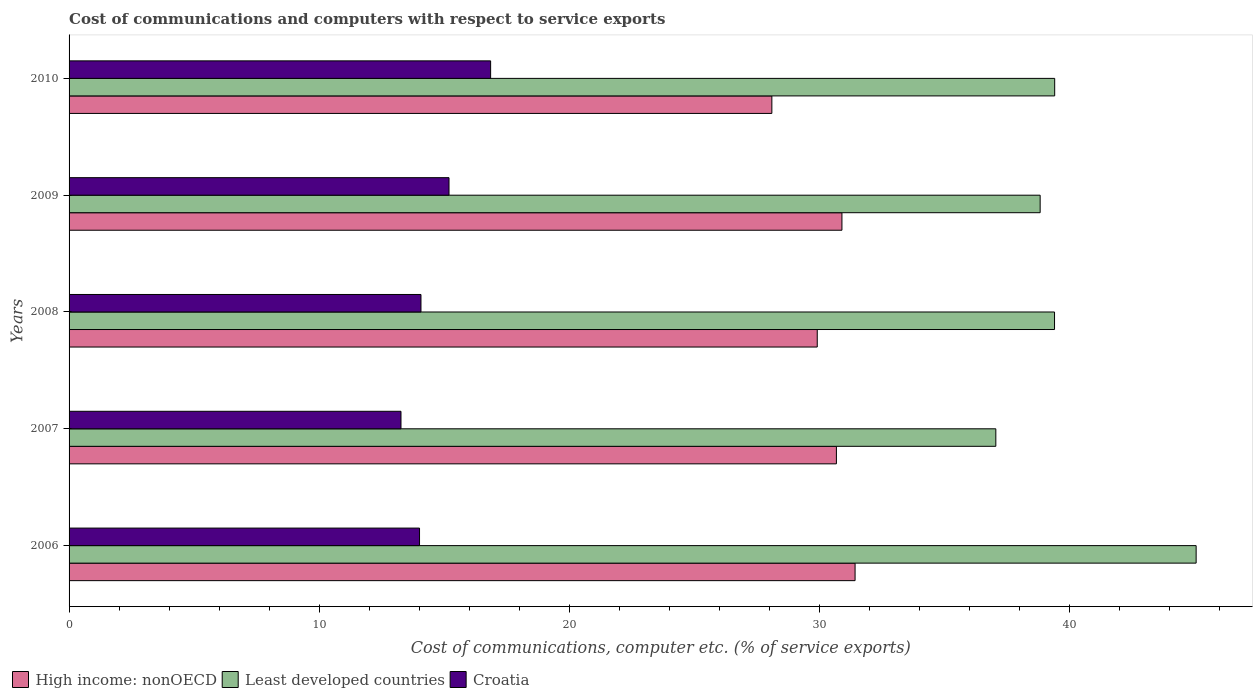How many different coloured bars are there?
Make the answer very short. 3. How many groups of bars are there?
Give a very brief answer. 5. How many bars are there on the 4th tick from the top?
Keep it short and to the point. 3. How many bars are there on the 3rd tick from the bottom?
Provide a succinct answer. 3. In how many cases, is the number of bars for a given year not equal to the number of legend labels?
Make the answer very short. 0. What is the cost of communications and computers in High income: nonOECD in 2006?
Your answer should be very brief. 31.42. Across all years, what is the maximum cost of communications and computers in Croatia?
Keep it short and to the point. 16.85. Across all years, what is the minimum cost of communications and computers in Least developed countries?
Your answer should be compact. 37.05. In which year was the cost of communications and computers in Croatia minimum?
Ensure brevity in your answer.  2007. What is the total cost of communications and computers in Croatia in the graph?
Your answer should be compact. 73.39. What is the difference between the cost of communications and computers in High income: nonOECD in 2007 and that in 2009?
Offer a very short reply. -0.22. What is the difference between the cost of communications and computers in High income: nonOECD in 2009 and the cost of communications and computers in Least developed countries in 2007?
Offer a terse response. -6.15. What is the average cost of communications and computers in Least developed countries per year?
Keep it short and to the point. 39.94. In the year 2010, what is the difference between the cost of communications and computers in Croatia and cost of communications and computers in Least developed countries?
Ensure brevity in your answer.  -22.55. In how many years, is the cost of communications and computers in Least developed countries greater than 26 %?
Your answer should be very brief. 5. What is the ratio of the cost of communications and computers in Croatia in 2008 to that in 2009?
Your answer should be compact. 0.93. What is the difference between the highest and the second highest cost of communications and computers in High income: nonOECD?
Ensure brevity in your answer.  0.53. What is the difference between the highest and the lowest cost of communications and computers in High income: nonOECD?
Make the answer very short. 3.33. In how many years, is the cost of communications and computers in High income: nonOECD greater than the average cost of communications and computers in High income: nonOECD taken over all years?
Offer a terse response. 3. What does the 1st bar from the top in 2010 represents?
Make the answer very short. Croatia. What does the 3rd bar from the bottom in 2010 represents?
Keep it short and to the point. Croatia. Is it the case that in every year, the sum of the cost of communications and computers in Least developed countries and cost of communications and computers in Croatia is greater than the cost of communications and computers in High income: nonOECD?
Your response must be concise. Yes. How many bars are there?
Make the answer very short. 15. Are all the bars in the graph horizontal?
Ensure brevity in your answer.  Yes. How many years are there in the graph?
Keep it short and to the point. 5. Where does the legend appear in the graph?
Provide a short and direct response. Bottom left. How are the legend labels stacked?
Make the answer very short. Horizontal. What is the title of the graph?
Your response must be concise. Cost of communications and computers with respect to service exports. What is the label or title of the X-axis?
Give a very brief answer. Cost of communications, computer etc. (% of service exports). What is the Cost of communications, computer etc. (% of service exports) of High income: nonOECD in 2006?
Your answer should be compact. 31.42. What is the Cost of communications, computer etc. (% of service exports) of Least developed countries in 2006?
Give a very brief answer. 45.06. What is the Cost of communications, computer etc. (% of service exports) in Croatia in 2006?
Provide a short and direct response. 14.01. What is the Cost of communications, computer etc. (% of service exports) of High income: nonOECD in 2007?
Offer a very short reply. 30.68. What is the Cost of communications, computer etc. (% of service exports) in Least developed countries in 2007?
Your response must be concise. 37.05. What is the Cost of communications, computer etc. (% of service exports) of Croatia in 2007?
Give a very brief answer. 13.27. What is the Cost of communications, computer etc. (% of service exports) of High income: nonOECD in 2008?
Your answer should be compact. 29.91. What is the Cost of communications, computer etc. (% of service exports) of Least developed countries in 2008?
Ensure brevity in your answer.  39.4. What is the Cost of communications, computer etc. (% of service exports) in Croatia in 2008?
Your answer should be very brief. 14.07. What is the Cost of communications, computer etc. (% of service exports) in High income: nonOECD in 2009?
Your answer should be compact. 30.9. What is the Cost of communications, computer etc. (% of service exports) in Least developed countries in 2009?
Your answer should be very brief. 38.82. What is the Cost of communications, computer etc. (% of service exports) in Croatia in 2009?
Keep it short and to the point. 15.19. What is the Cost of communications, computer etc. (% of service exports) of High income: nonOECD in 2010?
Provide a succinct answer. 28.09. What is the Cost of communications, computer etc. (% of service exports) of Least developed countries in 2010?
Your answer should be very brief. 39.4. What is the Cost of communications, computer etc. (% of service exports) in Croatia in 2010?
Offer a terse response. 16.85. Across all years, what is the maximum Cost of communications, computer etc. (% of service exports) in High income: nonOECD?
Your answer should be compact. 31.42. Across all years, what is the maximum Cost of communications, computer etc. (% of service exports) in Least developed countries?
Provide a succinct answer. 45.06. Across all years, what is the maximum Cost of communications, computer etc. (% of service exports) of Croatia?
Provide a short and direct response. 16.85. Across all years, what is the minimum Cost of communications, computer etc. (% of service exports) of High income: nonOECD?
Provide a short and direct response. 28.09. Across all years, what is the minimum Cost of communications, computer etc. (% of service exports) of Least developed countries?
Provide a short and direct response. 37.05. Across all years, what is the minimum Cost of communications, computer etc. (% of service exports) in Croatia?
Provide a succinct answer. 13.27. What is the total Cost of communications, computer etc. (% of service exports) in High income: nonOECD in the graph?
Provide a short and direct response. 151. What is the total Cost of communications, computer etc. (% of service exports) in Least developed countries in the graph?
Your answer should be compact. 199.72. What is the total Cost of communications, computer etc. (% of service exports) of Croatia in the graph?
Your answer should be very brief. 73.39. What is the difference between the Cost of communications, computer etc. (% of service exports) of High income: nonOECD in 2006 and that in 2007?
Offer a terse response. 0.75. What is the difference between the Cost of communications, computer etc. (% of service exports) of Least developed countries in 2006 and that in 2007?
Offer a very short reply. 8.01. What is the difference between the Cost of communications, computer etc. (% of service exports) in Croatia in 2006 and that in 2007?
Offer a terse response. 0.74. What is the difference between the Cost of communications, computer etc. (% of service exports) in High income: nonOECD in 2006 and that in 2008?
Your response must be concise. 1.51. What is the difference between the Cost of communications, computer etc. (% of service exports) in Least developed countries in 2006 and that in 2008?
Ensure brevity in your answer.  5.66. What is the difference between the Cost of communications, computer etc. (% of service exports) of Croatia in 2006 and that in 2008?
Offer a very short reply. -0.06. What is the difference between the Cost of communications, computer etc. (% of service exports) in High income: nonOECD in 2006 and that in 2009?
Your answer should be very brief. 0.53. What is the difference between the Cost of communications, computer etc. (% of service exports) of Least developed countries in 2006 and that in 2009?
Your answer should be very brief. 6.24. What is the difference between the Cost of communications, computer etc. (% of service exports) of Croatia in 2006 and that in 2009?
Offer a very short reply. -1.18. What is the difference between the Cost of communications, computer etc. (% of service exports) of High income: nonOECD in 2006 and that in 2010?
Ensure brevity in your answer.  3.33. What is the difference between the Cost of communications, computer etc. (% of service exports) of Least developed countries in 2006 and that in 2010?
Provide a short and direct response. 5.65. What is the difference between the Cost of communications, computer etc. (% of service exports) of Croatia in 2006 and that in 2010?
Your answer should be very brief. -2.84. What is the difference between the Cost of communications, computer etc. (% of service exports) in High income: nonOECD in 2007 and that in 2008?
Give a very brief answer. 0.77. What is the difference between the Cost of communications, computer etc. (% of service exports) in Least developed countries in 2007 and that in 2008?
Offer a terse response. -2.35. What is the difference between the Cost of communications, computer etc. (% of service exports) of Croatia in 2007 and that in 2008?
Give a very brief answer. -0.8. What is the difference between the Cost of communications, computer etc. (% of service exports) in High income: nonOECD in 2007 and that in 2009?
Your answer should be compact. -0.22. What is the difference between the Cost of communications, computer etc. (% of service exports) in Least developed countries in 2007 and that in 2009?
Your response must be concise. -1.77. What is the difference between the Cost of communications, computer etc. (% of service exports) of Croatia in 2007 and that in 2009?
Your response must be concise. -1.92. What is the difference between the Cost of communications, computer etc. (% of service exports) in High income: nonOECD in 2007 and that in 2010?
Make the answer very short. 2.58. What is the difference between the Cost of communications, computer etc. (% of service exports) in Least developed countries in 2007 and that in 2010?
Give a very brief answer. -2.35. What is the difference between the Cost of communications, computer etc. (% of service exports) of Croatia in 2007 and that in 2010?
Provide a succinct answer. -3.58. What is the difference between the Cost of communications, computer etc. (% of service exports) of High income: nonOECD in 2008 and that in 2009?
Offer a very short reply. -0.99. What is the difference between the Cost of communications, computer etc. (% of service exports) in Least developed countries in 2008 and that in 2009?
Keep it short and to the point. 0.57. What is the difference between the Cost of communications, computer etc. (% of service exports) in Croatia in 2008 and that in 2009?
Ensure brevity in your answer.  -1.12. What is the difference between the Cost of communications, computer etc. (% of service exports) of High income: nonOECD in 2008 and that in 2010?
Keep it short and to the point. 1.81. What is the difference between the Cost of communications, computer etc. (% of service exports) in Least developed countries in 2008 and that in 2010?
Make the answer very short. -0.01. What is the difference between the Cost of communications, computer etc. (% of service exports) of Croatia in 2008 and that in 2010?
Your answer should be compact. -2.78. What is the difference between the Cost of communications, computer etc. (% of service exports) of High income: nonOECD in 2009 and that in 2010?
Your answer should be very brief. 2.8. What is the difference between the Cost of communications, computer etc. (% of service exports) of Least developed countries in 2009 and that in 2010?
Provide a succinct answer. -0.58. What is the difference between the Cost of communications, computer etc. (% of service exports) in Croatia in 2009 and that in 2010?
Offer a terse response. -1.66. What is the difference between the Cost of communications, computer etc. (% of service exports) in High income: nonOECD in 2006 and the Cost of communications, computer etc. (% of service exports) in Least developed countries in 2007?
Make the answer very short. -5.63. What is the difference between the Cost of communications, computer etc. (% of service exports) of High income: nonOECD in 2006 and the Cost of communications, computer etc. (% of service exports) of Croatia in 2007?
Offer a terse response. 18.15. What is the difference between the Cost of communications, computer etc. (% of service exports) of Least developed countries in 2006 and the Cost of communications, computer etc. (% of service exports) of Croatia in 2007?
Offer a terse response. 31.79. What is the difference between the Cost of communications, computer etc. (% of service exports) of High income: nonOECD in 2006 and the Cost of communications, computer etc. (% of service exports) of Least developed countries in 2008?
Offer a very short reply. -7.97. What is the difference between the Cost of communications, computer etc. (% of service exports) in High income: nonOECD in 2006 and the Cost of communications, computer etc. (% of service exports) in Croatia in 2008?
Your response must be concise. 17.35. What is the difference between the Cost of communications, computer etc. (% of service exports) of Least developed countries in 2006 and the Cost of communications, computer etc. (% of service exports) of Croatia in 2008?
Provide a succinct answer. 30.99. What is the difference between the Cost of communications, computer etc. (% of service exports) in High income: nonOECD in 2006 and the Cost of communications, computer etc. (% of service exports) in Least developed countries in 2009?
Offer a terse response. -7.4. What is the difference between the Cost of communications, computer etc. (% of service exports) of High income: nonOECD in 2006 and the Cost of communications, computer etc. (% of service exports) of Croatia in 2009?
Keep it short and to the point. 16.23. What is the difference between the Cost of communications, computer etc. (% of service exports) in Least developed countries in 2006 and the Cost of communications, computer etc. (% of service exports) in Croatia in 2009?
Your response must be concise. 29.87. What is the difference between the Cost of communications, computer etc. (% of service exports) of High income: nonOECD in 2006 and the Cost of communications, computer etc. (% of service exports) of Least developed countries in 2010?
Your response must be concise. -7.98. What is the difference between the Cost of communications, computer etc. (% of service exports) in High income: nonOECD in 2006 and the Cost of communications, computer etc. (% of service exports) in Croatia in 2010?
Offer a terse response. 14.57. What is the difference between the Cost of communications, computer etc. (% of service exports) of Least developed countries in 2006 and the Cost of communications, computer etc. (% of service exports) of Croatia in 2010?
Your answer should be very brief. 28.2. What is the difference between the Cost of communications, computer etc. (% of service exports) of High income: nonOECD in 2007 and the Cost of communications, computer etc. (% of service exports) of Least developed countries in 2008?
Your answer should be compact. -8.72. What is the difference between the Cost of communications, computer etc. (% of service exports) in High income: nonOECD in 2007 and the Cost of communications, computer etc. (% of service exports) in Croatia in 2008?
Ensure brevity in your answer.  16.61. What is the difference between the Cost of communications, computer etc. (% of service exports) of Least developed countries in 2007 and the Cost of communications, computer etc. (% of service exports) of Croatia in 2008?
Your answer should be compact. 22.98. What is the difference between the Cost of communications, computer etc. (% of service exports) of High income: nonOECD in 2007 and the Cost of communications, computer etc. (% of service exports) of Least developed countries in 2009?
Your response must be concise. -8.15. What is the difference between the Cost of communications, computer etc. (% of service exports) in High income: nonOECD in 2007 and the Cost of communications, computer etc. (% of service exports) in Croatia in 2009?
Your response must be concise. 15.49. What is the difference between the Cost of communications, computer etc. (% of service exports) in Least developed countries in 2007 and the Cost of communications, computer etc. (% of service exports) in Croatia in 2009?
Offer a very short reply. 21.86. What is the difference between the Cost of communications, computer etc. (% of service exports) of High income: nonOECD in 2007 and the Cost of communications, computer etc. (% of service exports) of Least developed countries in 2010?
Keep it short and to the point. -8.73. What is the difference between the Cost of communications, computer etc. (% of service exports) in High income: nonOECD in 2007 and the Cost of communications, computer etc. (% of service exports) in Croatia in 2010?
Provide a succinct answer. 13.82. What is the difference between the Cost of communications, computer etc. (% of service exports) of Least developed countries in 2007 and the Cost of communications, computer etc. (% of service exports) of Croatia in 2010?
Offer a very short reply. 20.2. What is the difference between the Cost of communications, computer etc. (% of service exports) in High income: nonOECD in 2008 and the Cost of communications, computer etc. (% of service exports) in Least developed countries in 2009?
Give a very brief answer. -8.91. What is the difference between the Cost of communications, computer etc. (% of service exports) of High income: nonOECD in 2008 and the Cost of communications, computer etc. (% of service exports) of Croatia in 2009?
Your response must be concise. 14.72. What is the difference between the Cost of communications, computer etc. (% of service exports) in Least developed countries in 2008 and the Cost of communications, computer etc. (% of service exports) in Croatia in 2009?
Make the answer very short. 24.21. What is the difference between the Cost of communications, computer etc. (% of service exports) in High income: nonOECD in 2008 and the Cost of communications, computer etc. (% of service exports) in Least developed countries in 2010?
Provide a succinct answer. -9.49. What is the difference between the Cost of communications, computer etc. (% of service exports) in High income: nonOECD in 2008 and the Cost of communications, computer etc. (% of service exports) in Croatia in 2010?
Keep it short and to the point. 13.06. What is the difference between the Cost of communications, computer etc. (% of service exports) of Least developed countries in 2008 and the Cost of communications, computer etc. (% of service exports) of Croatia in 2010?
Your answer should be very brief. 22.54. What is the difference between the Cost of communications, computer etc. (% of service exports) of High income: nonOECD in 2009 and the Cost of communications, computer etc. (% of service exports) of Least developed countries in 2010?
Provide a succinct answer. -8.5. What is the difference between the Cost of communications, computer etc. (% of service exports) of High income: nonOECD in 2009 and the Cost of communications, computer etc. (% of service exports) of Croatia in 2010?
Provide a short and direct response. 14.04. What is the difference between the Cost of communications, computer etc. (% of service exports) in Least developed countries in 2009 and the Cost of communications, computer etc. (% of service exports) in Croatia in 2010?
Your answer should be very brief. 21.97. What is the average Cost of communications, computer etc. (% of service exports) in High income: nonOECD per year?
Offer a terse response. 30.2. What is the average Cost of communications, computer etc. (% of service exports) in Least developed countries per year?
Ensure brevity in your answer.  39.94. What is the average Cost of communications, computer etc. (% of service exports) in Croatia per year?
Your answer should be very brief. 14.68. In the year 2006, what is the difference between the Cost of communications, computer etc. (% of service exports) of High income: nonOECD and Cost of communications, computer etc. (% of service exports) of Least developed countries?
Offer a terse response. -13.63. In the year 2006, what is the difference between the Cost of communications, computer etc. (% of service exports) in High income: nonOECD and Cost of communications, computer etc. (% of service exports) in Croatia?
Offer a terse response. 17.41. In the year 2006, what is the difference between the Cost of communications, computer etc. (% of service exports) in Least developed countries and Cost of communications, computer etc. (% of service exports) in Croatia?
Offer a very short reply. 31.05. In the year 2007, what is the difference between the Cost of communications, computer etc. (% of service exports) of High income: nonOECD and Cost of communications, computer etc. (% of service exports) of Least developed countries?
Make the answer very short. -6.37. In the year 2007, what is the difference between the Cost of communications, computer etc. (% of service exports) of High income: nonOECD and Cost of communications, computer etc. (% of service exports) of Croatia?
Make the answer very short. 17.41. In the year 2007, what is the difference between the Cost of communications, computer etc. (% of service exports) in Least developed countries and Cost of communications, computer etc. (% of service exports) in Croatia?
Offer a very short reply. 23.78. In the year 2008, what is the difference between the Cost of communications, computer etc. (% of service exports) of High income: nonOECD and Cost of communications, computer etc. (% of service exports) of Least developed countries?
Make the answer very short. -9.49. In the year 2008, what is the difference between the Cost of communications, computer etc. (% of service exports) of High income: nonOECD and Cost of communications, computer etc. (% of service exports) of Croatia?
Keep it short and to the point. 15.84. In the year 2008, what is the difference between the Cost of communications, computer etc. (% of service exports) of Least developed countries and Cost of communications, computer etc. (% of service exports) of Croatia?
Ensure brevity in your answer.  25.33. In the year 2009, what is the difference between the Cost of communications, computer etc. (% of service exports) in High income: nonOECD and Cost of communications, computer etc. (% of service exports) in Least developed countries?
Offer a terse response. -7.92. In the year 2009, what is the difference between the Cost of communications, computer etc. (% of service exports) of High income: nonOECD and Cost of communications, computer etc. (% of service exports) of Croatia?
Make the answer very short. 15.71. In the year 2009, what is the difference between the Cost of communications, computer etc. (% of service exports) of Least developed countries and Cost of communications, computer etc. (% of service exports) of Croatia?
Ensure brevity in your answer.  23.63. In the year 2010, what is the difference between the Cost of communications, computer etc. (% of service exports) in High income: nonOECD and Cost of communications, computer etc. (% of service exports) in Least developed countries?
Keep it short and to the point. -11.31. In the year 2010, what is the difference between the Cost of communications, computer etc. (% of service exports) in High income: nonOECD and Cost of communications, computer etc. (% of service exports) in Croatia?
Your answer should be compact. 11.24. In the year 2010, what is the difference between the Cost of communications, computer etc. (% of service exports) of Least developed countries and Cost of communications, computer etc. (% of service exports) of Croatia?
Ensure brevity in your answer.  22.55. What is the ratio of the Cost of communications, computer etc. (% of service exports) of High income: nonOECD in 2006 to that in 2007?
Make the answer very short. 1.02. What is the ratio of the Cost of communications, computer etc. (% of service exports) in Least developed countries in 2006 to that in 2007?
Ensure brevity in your answer.  1.22. What is the ratio of the Cost of communications, computer etc. (% of service exports) in Croatia in 2006 to that in 2007?
Provide a succinct answer. 1.06. What is the ratio of the Cost of communications, computer etc. (% of service exports) of High income: nonOECD in 2006 to that in 2008?
Give a very brief answer. 1.05. What is the ratio of the Cost of communications, computer etc. (% of service exports) of Least developed countries in 2006 to that in 2008?
Provide a short and direct response. 1.14. What is the ratio of the Cost of communications, computer etc. (% of service exports) of Croatia in 2006 to that in 2008?
Ensure brevity in your answer.  1. What is the ratio of the Cost of communications, computer etc. (% of service exports) in High income: nonOECD in 2006 to that in 2009?
Offer a terse response. 1.02. What is the ratio of the Cost of communications, computer etc. (% of service exports) of Least developed countries in 2006 to that in 2009?
Give a very brief answer. 1.16. What is the ratio of the Cost of communications, computer etc. (% of service exports) of Croatia in 2006 to that in 2009?
Keep it short and to the point. 0.92. What is the ratio of the Cost of communications, computer etc. (% of service exports) of High income: nonOECD in 2006 to that in 2010?
Give a very brief answer. 1.12. What is the ratio of the Cost of communications, computer etc. (% of service exports) of Least developed countries in 2006 to that in 2010?
Ensure brevity in your answer.  1.14. What is the ratio of the Cost of communications, computer etc. (% of service exports) in Croatia in 2006 to that in 2010?
Offer a very short reply. 0.83. What is the ratio of the Cost of communications, computer etc. (% of service exports) in High income: nonOECD in 2007 to that in 2008?
Offer a very short reply. 1.03. What is the ratio of the Cost of communications, computer etc. (% of service exports) in Least developed countries in 2007 to that in 2008?
Your answer should be compact. 0.94. What is the ratio of the Cost of communications, computer etc. (% of service exports) in Croatia in 2007 to that in 2008?
Offer a very short reply. 0.94. What is the ratio of the Cost of communications, computer etc. (% of service exports) in High income: nonOECD in 2007 to that in 2009?
Make the answer very short. 0.99. What is the ratio of the Cost of communications, computer etc. (% of service exports) in Least developed countries in 2007 to that in 2009?
Your answer should be very brief. 0.95. What is the ratio of the Cost of communications, computer etc. (% of service exports) of Croatia in 2007 to that in 2009?
Your answer should be compact. 0.87. What is the ratio of the Cost of communications, computer etc. (% of service exports) of High income: nonOECD in 2007 to that in 2010?
Keep it short and to the point. 1.09. What is the ratio of the Cost of communications, computer etc. (% of service exports) of Least developed countries in 2007 to that in 2010?
Your answer should be compact. 0.94. What is the ratio of the Cost of communications, computer etc. (% of service exports) in Croatia in 2007 to that in 2010?
Keep it short and to the point. 0.79. What is the ratio of the Cost of communications, computer etc. (% of service exports) of Least developed countries in 2008 to that in 2009?
Ensure brevity in your answer.  1.01. What is the ratio of the Cost of communications, computer etc. (% of service exports) of Croatia in 2008 to that in 2009?
Give a very brief answer. 0.93. What is the ratio of the Cost of communications, computer etc. (% of service exports) in High income: nonOECD in 2008 to that in 2010?
Provide a short and direct response. 1.06. What is the ratio of the Cost of communications, computer etc. (% of service exports) in Least developed countries in 2008 to that in 2010?
Provide a short and direct response. 1. What is the ratio of the Cost of communications, computer etc. (% of service exports) of Croatia in 2008 to that in 2010?
Your answer should be compact. 0.83. What is the ratio of the Cost of communications, computer etc. (% of service exports) of High income: nonOECD in 2009 to that in 2010?
Your answer should be very brief. 1.1. What is the ratio of the Cost of communications, computer etc. (% of service exports) in Croatia in 2009 to that in 2010?
Make the answer very short. 0.9. What is the difference between the highest and the second highest Cost of communications, computer etc. (% of service exports) in High income: nonOECD?
Keep it short and to the point. 0.53. What is the difference between the highest and the second highest Cost of communications, computer etc. (% of service exports) in Least developed countries?
Offer a very short reply. 5.65. What is the difference between the highest and the second highest Cost of communications, computer etc. (% of service exports) in Croatia?
Offer a terse response. 1.66. What is the difference between the highest and the lowest Cost of communications, computer etc. (% of service exports) in High income: nonOECD?
Your answer should be very brief. 3.33. What is the difference between the highest and the lowest Cost of communications, computer etc. (% of service exports) in Least developed countries?
Offer a terse response. 8.01. What is the difference between the highest and the lowest Cost of communications, computer etc. (% of service exports) in Croatia?
Offer a terse response. 3.58. 